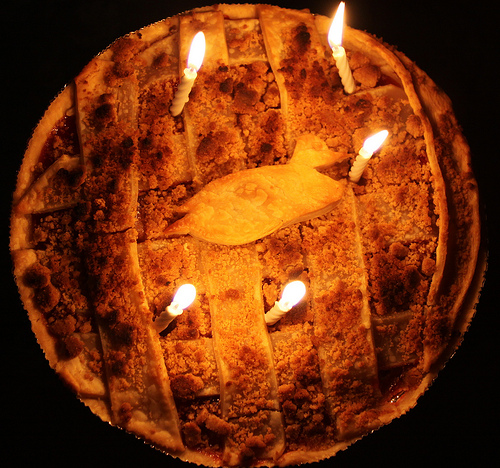<image>
Is there a fire above the crust? Yes. The fire is positioned above the crust in the vertical space, higher up in the scene. 